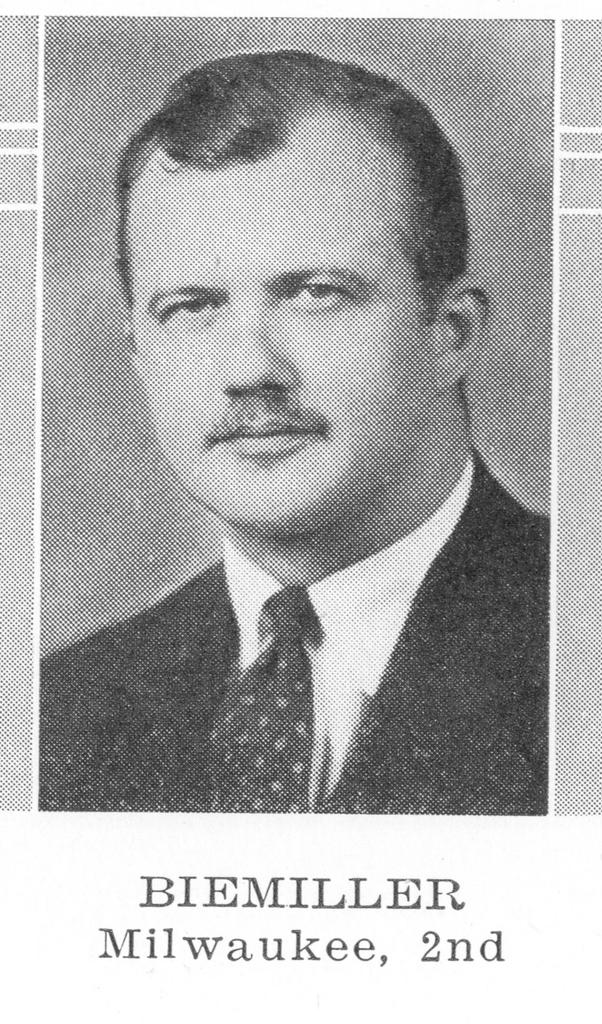Who is present in the image? There is a man in the image. What is the man wearing? The man is wearing a coat and a tie. Is there any text visible in the image? Yes, there is text written on the image, presumably on the man's coat. How many cows can be seen grazing in the background of the image? There are no cows present in the image; it features a man wearing a coat and tie with text on it. What type of tomatoes are being used to create the text on the man's coat? There are no tomatoes present in the image, and the text on the man's coat is not made of tomatoes. 